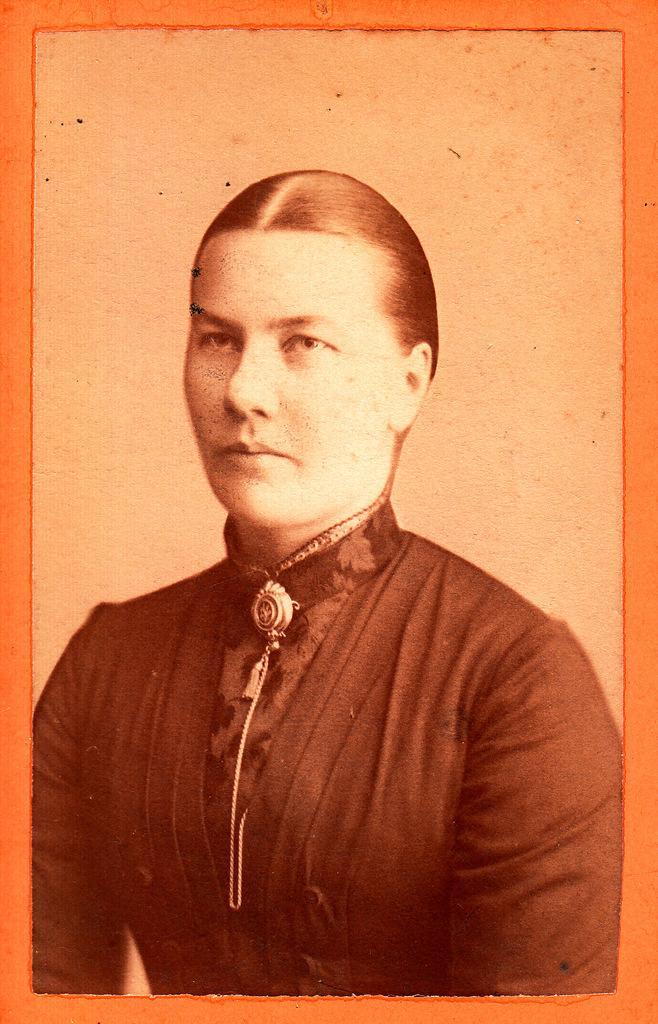Can you describe this image briefly? In this image we can see a picture of a woman wearing a black dress. 